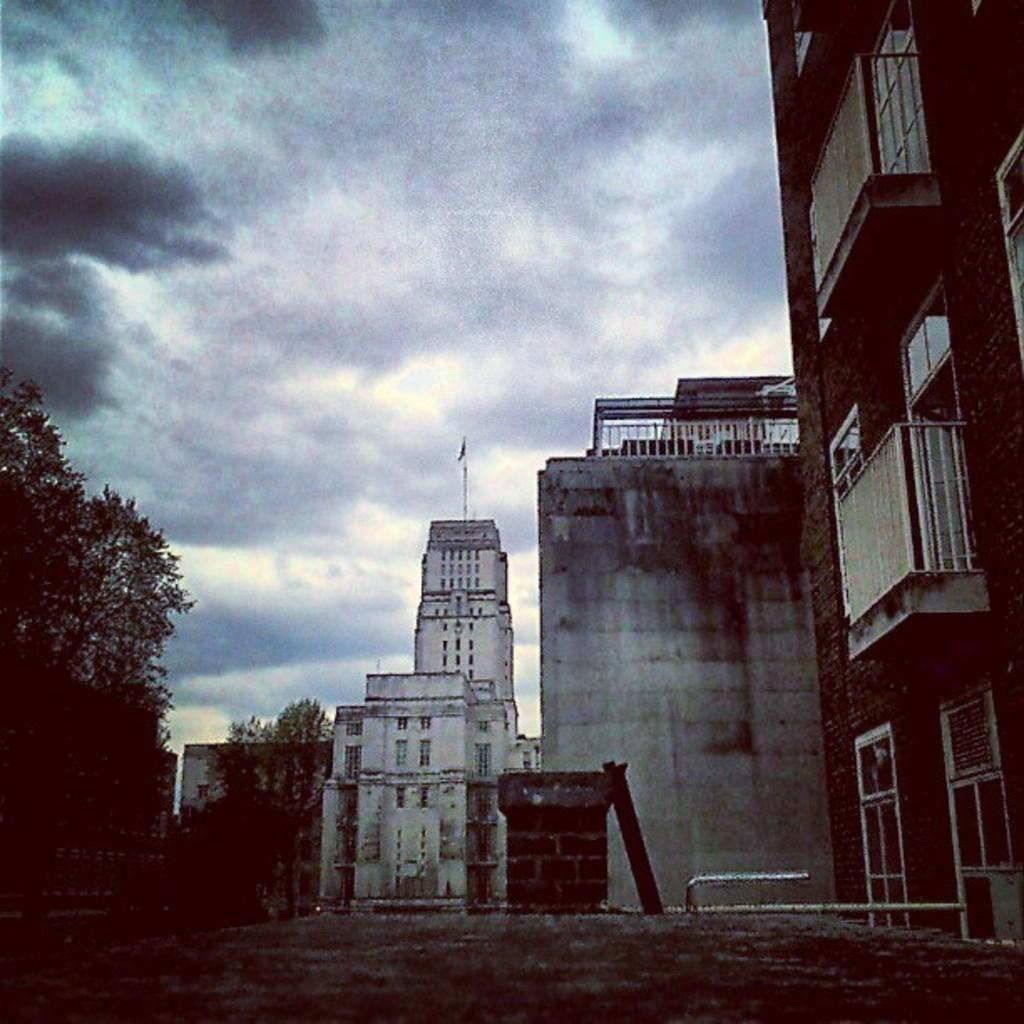What type of man-made structure can be seen in the image? There are buildings in the image. What is the primary surface visible in the image? There is a road in the image. What type of natural elements are present in the image? There are trees in the image. What type of objects can be seen in the image? There are rods in the image. What is visible in the background of the image? The sky is visible in the background of the image. What can be observed in the sky? Clouds are present in the sky. What type of language is spoken by the trees in the image? Trees do not speak any language; they are plants and do not have the ability to communicate verbally. What type of furniture can be seen on the roof of the buildings in the image? There is no furniture visible on the roofs of the buildings in the image. 